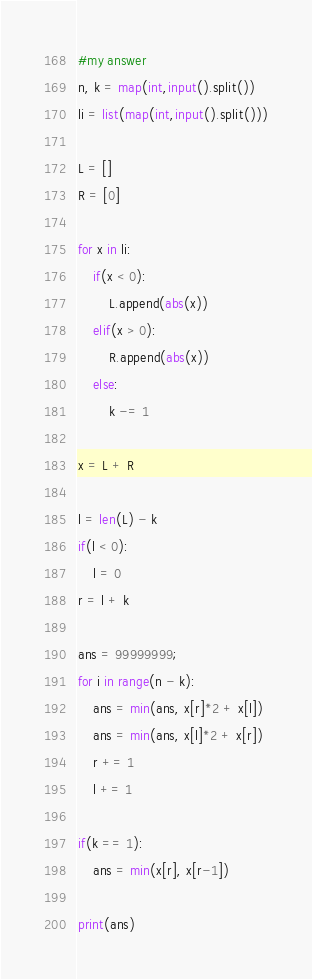<code> <loc_0><loc_0><loc_500><loc_500><_Python_>#my answer
n, k = map(int,input().split())
li = list(map(int,input().split()))

L = []
R = [0]

for x in li:
    if(x < 0):
        L.append(abs(x))
    elif(x > 0):
        R.append(abs(x))
    else:
        k -= 1
        
x = L + R

l = len(L) - k
if(l < 0):
    l = 0
r = l + k

ans = 99999999;
for i in range(n - k):
    ans = min(ans, x[r]*2 + x[l])
    ans = min(ans, x[l]*2 + x[r])
    r += 1
    l += 1
    
if(k == 1):
    ans = min(x[r], x[r-1])
    
print(ans)</code> 